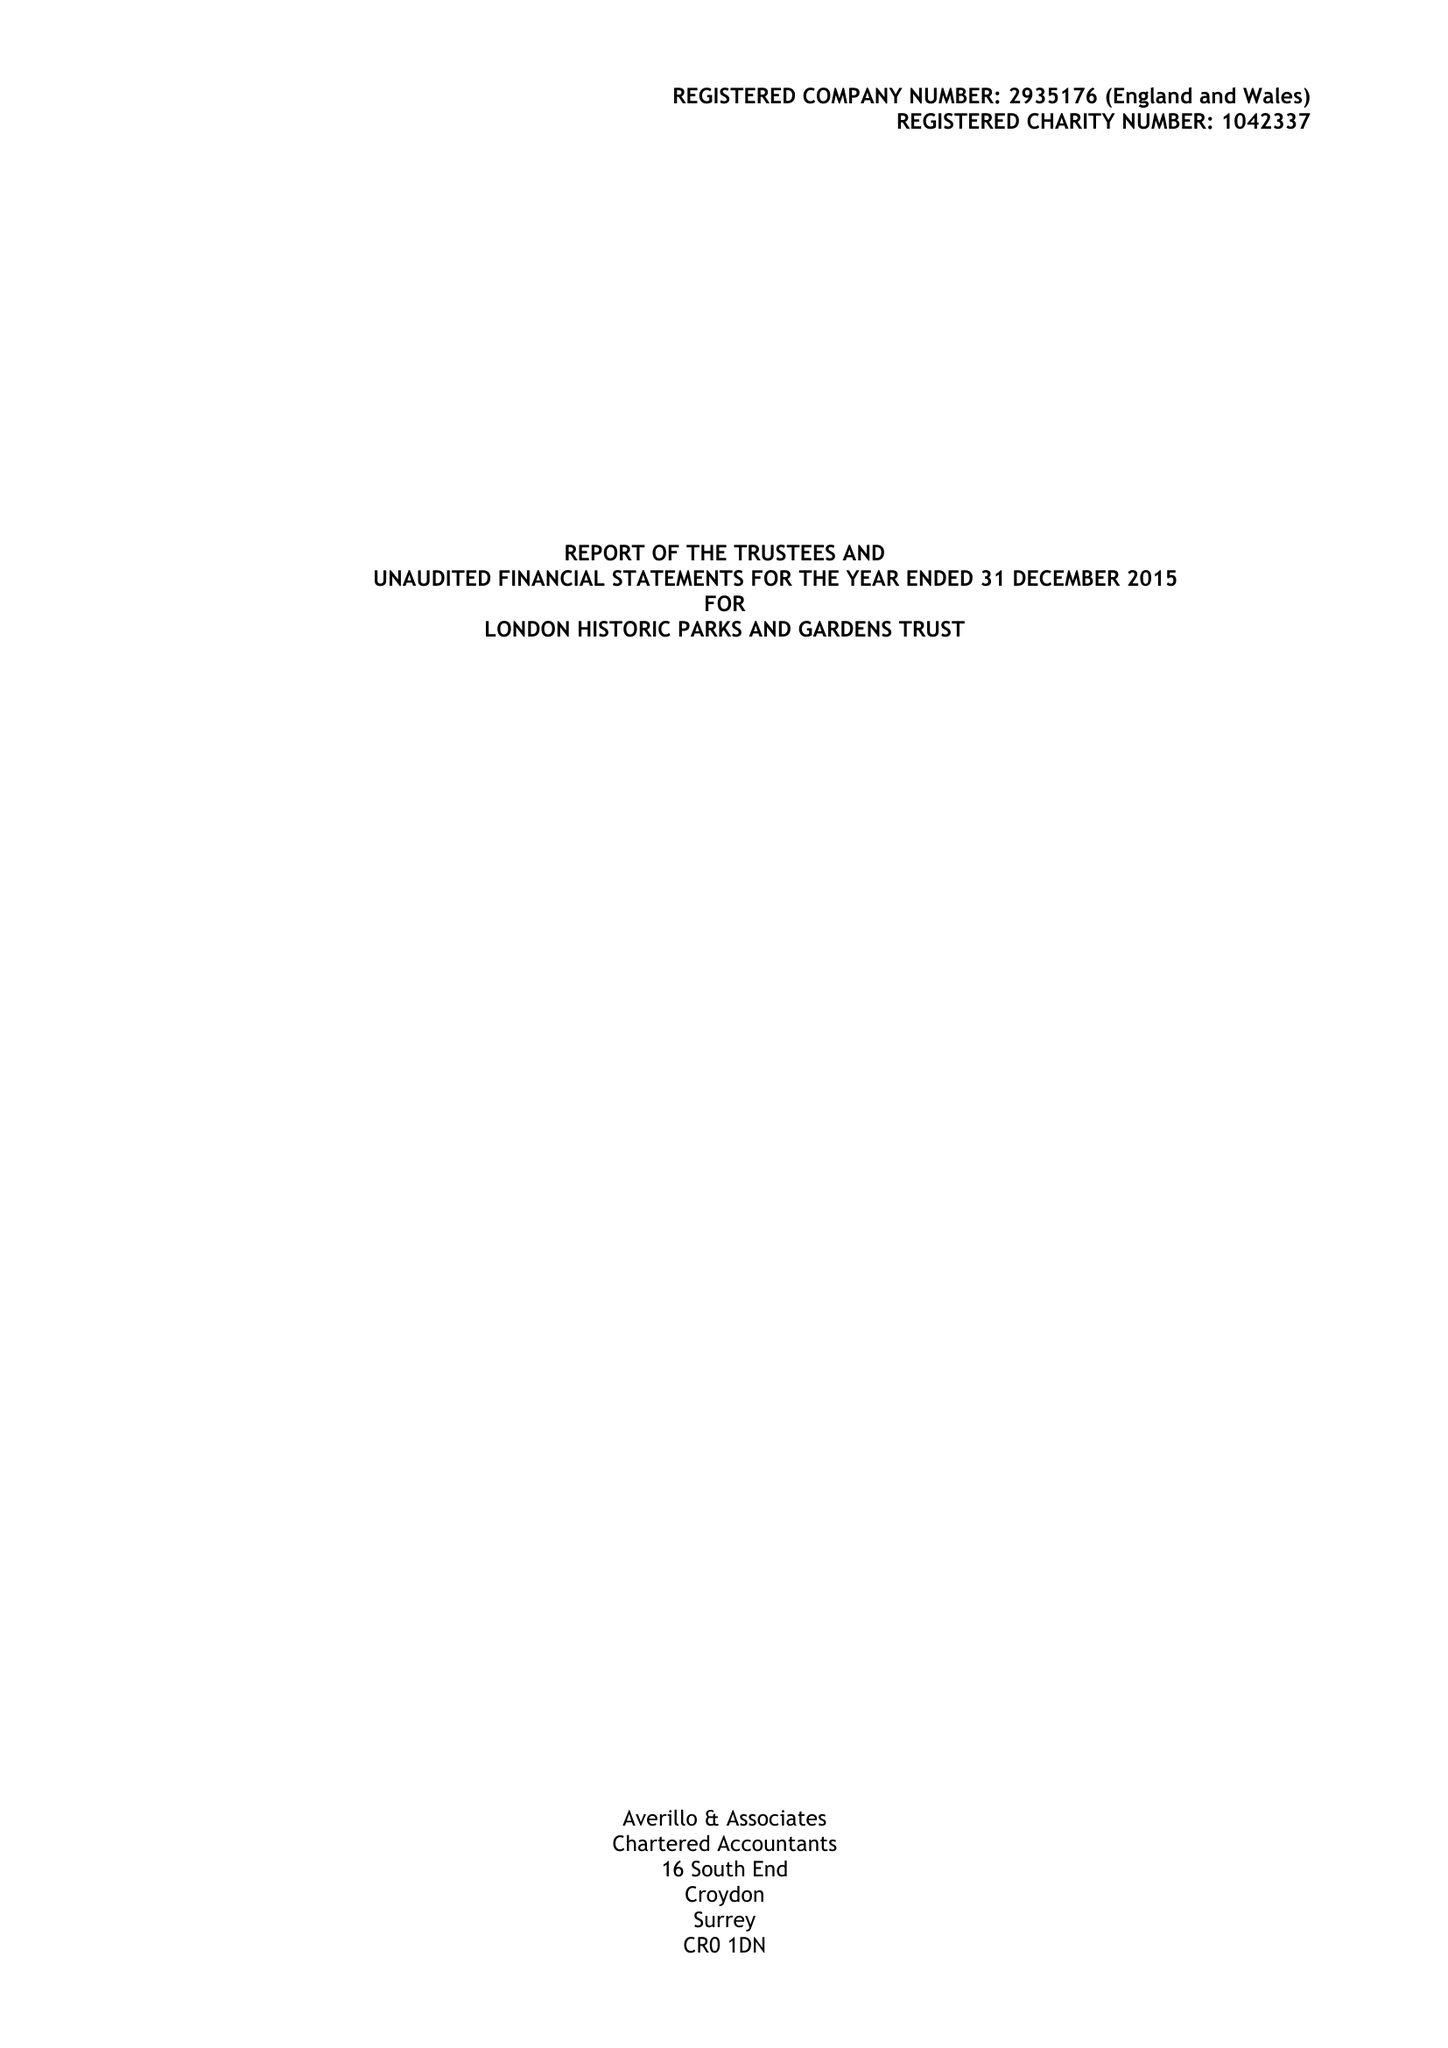What is the value for the address__postcode?
Answer the question using a single word or phrase. SW1A 2BJ 